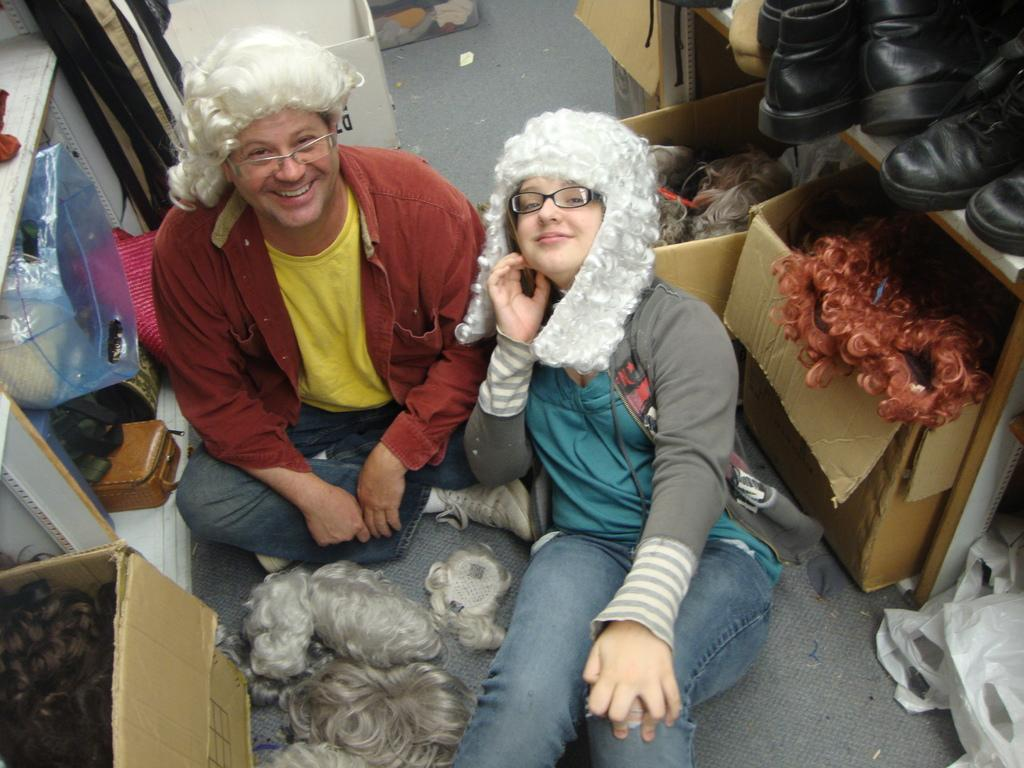What are the people in the image doing? The people in the image are sitting on the floor. What can be seen on the shelves in the image? There are big boxes on the shelves in the image. What is the income of the people sitting on the floor in the image? There is no information about the income of the people in the image. How much destruction is caused by the big boxes on the shelves in the image? There is no destruction caused by the big boxes on the shelves in the image; they are simply sitting on the shelves. 